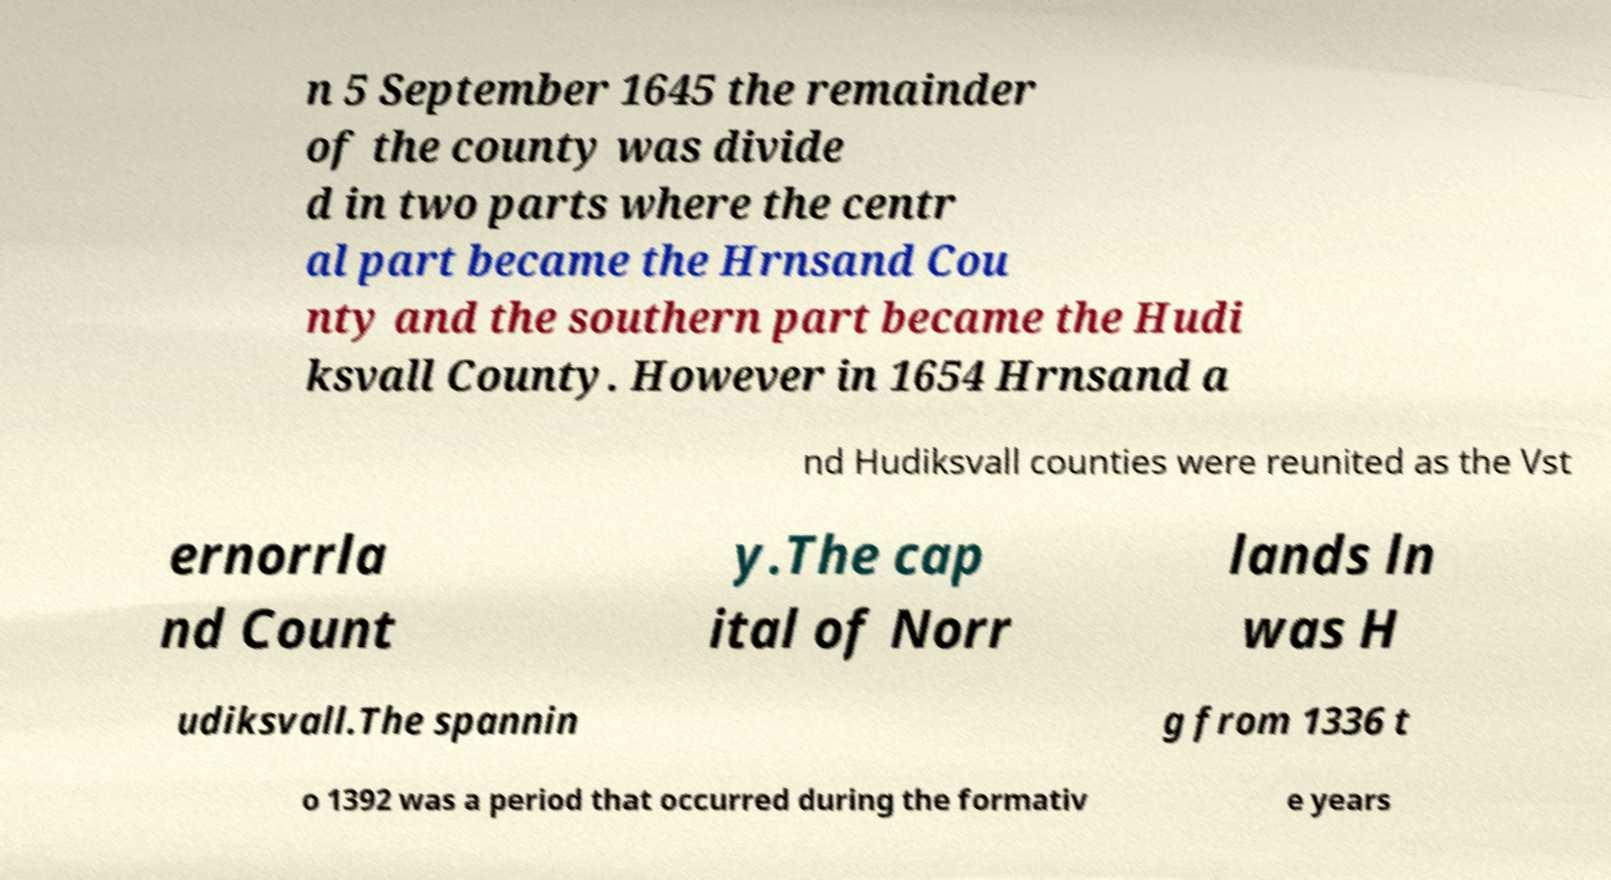I need the written content from this picture converted into text. Can you do that? n 5 September 1645 the remainder of the county was divide d in two parts where the centr al part became the Hrnsand Cou nty and the southern part became the Hudi ksvall County. However in 1654 Hrnsand a nd Hudiksvall counties were reunited as the Vst ernorrla nd Count y.The cap ital of Norr lands ln was H udiksvall.The spannin g from 1336 t o 1392 was a period that occurred during the formativ e years 